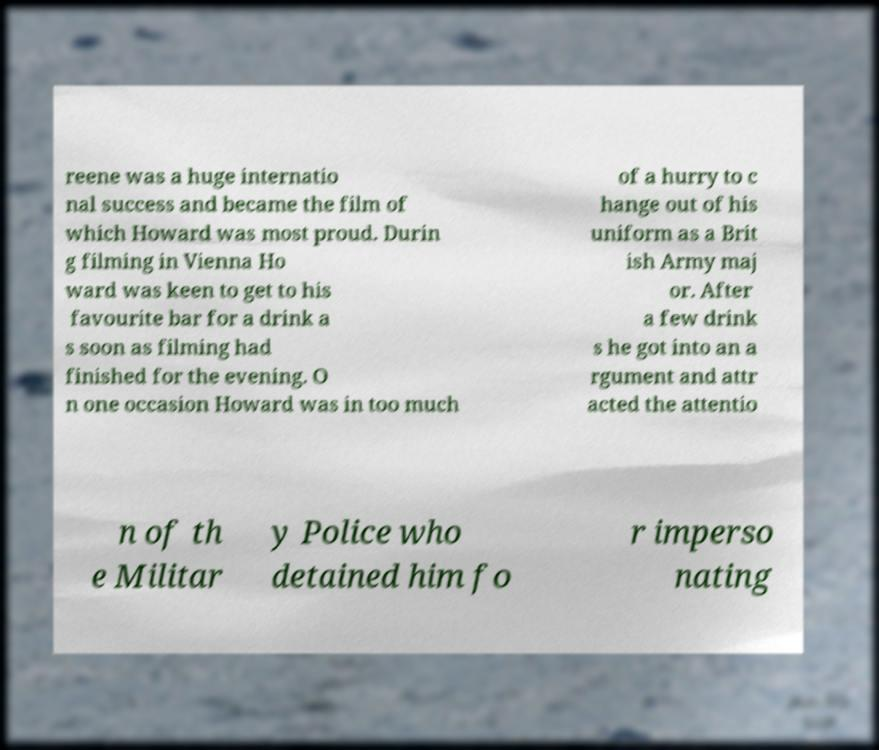Please identify and transcribe the text found in this image. reene was a huge internatio nal success and became the film of which Howard was most proud. Durin g filming in Vienna Ho ward was keen to get to his favourite bar for a drink a s soon as filming had finished for the evening. O n one occasion Howard was in too much of a hurry to c hange out of his uniform as a Brit ish Army maj or. After a few drink s he got into an a rgument and attr acted the attentio n of th e Militar y Police who detained him fo r imperso nating 